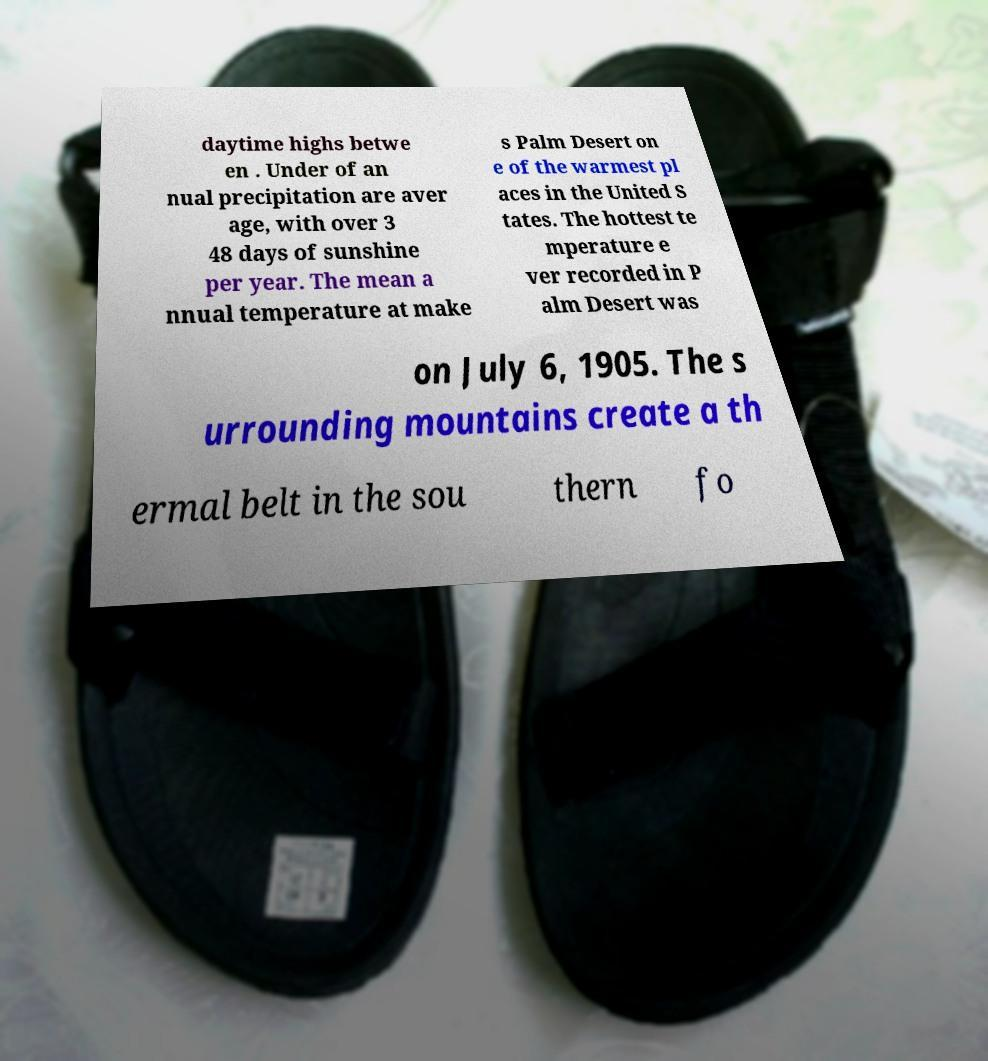What messages or text are displayed in this image? I need them in a readable, typed format. daytime highs betwe en . Under of an nual precipitation are aver age, with over 3 48 days of sunshine per year. The mean a nnual temperature at make s Palm Desert on e of the warmest pl aces in the United S tates. The hottest te mperature e ver recorded in P alm Desert was on July 6, 1905. The s urrounding mountains create a th ermal belt in the sou thern fo 